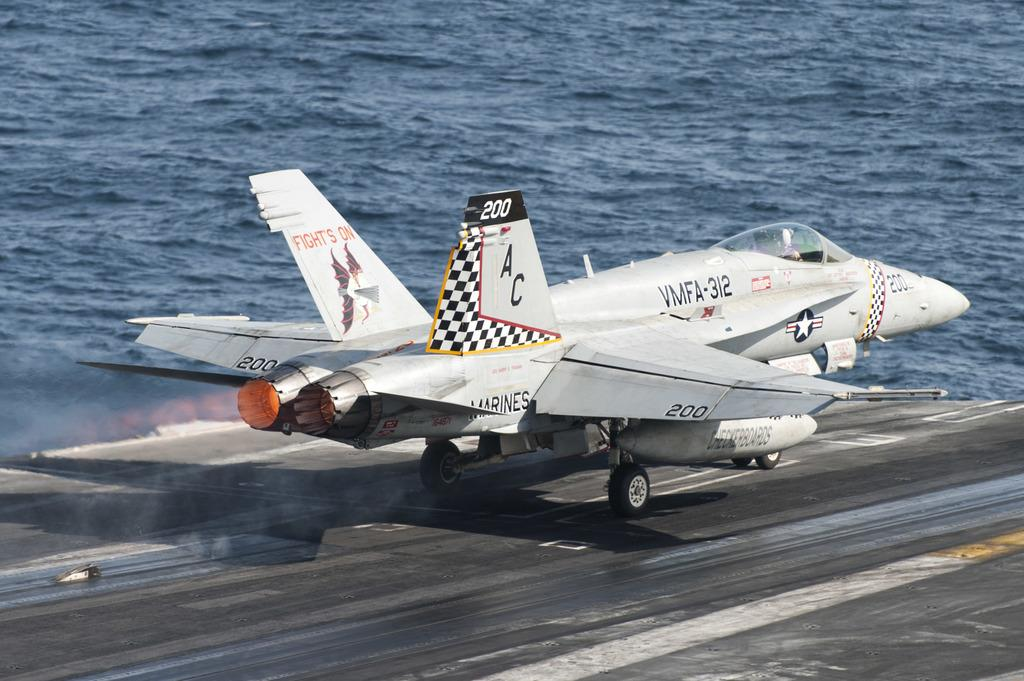Provide a one-sentence caption for the provided image. A fighter jet labeled VMFA-312 is taking off from a aircraft carrier. 